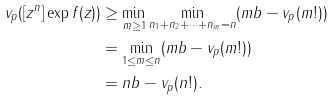Convert formula to latex. <formula><loc_0><loc_0><loc_500><loc_500>v _ { p } ( [ z ^ { n } ] \exp f ( z ) ) & \geq \min _ { m \geq 1 } \min _ { n _ { 1 } + n _ { 2 } + \dots + n _ { m } = n } ( m b - v _ { p } ( m ! ) ) \\ & = \min _ { 1 \leq m \leq n } ( m b - v _ { p } ( m ! ) ) \\ & = n b - v _ { p } ( n ! ) .</formula> 